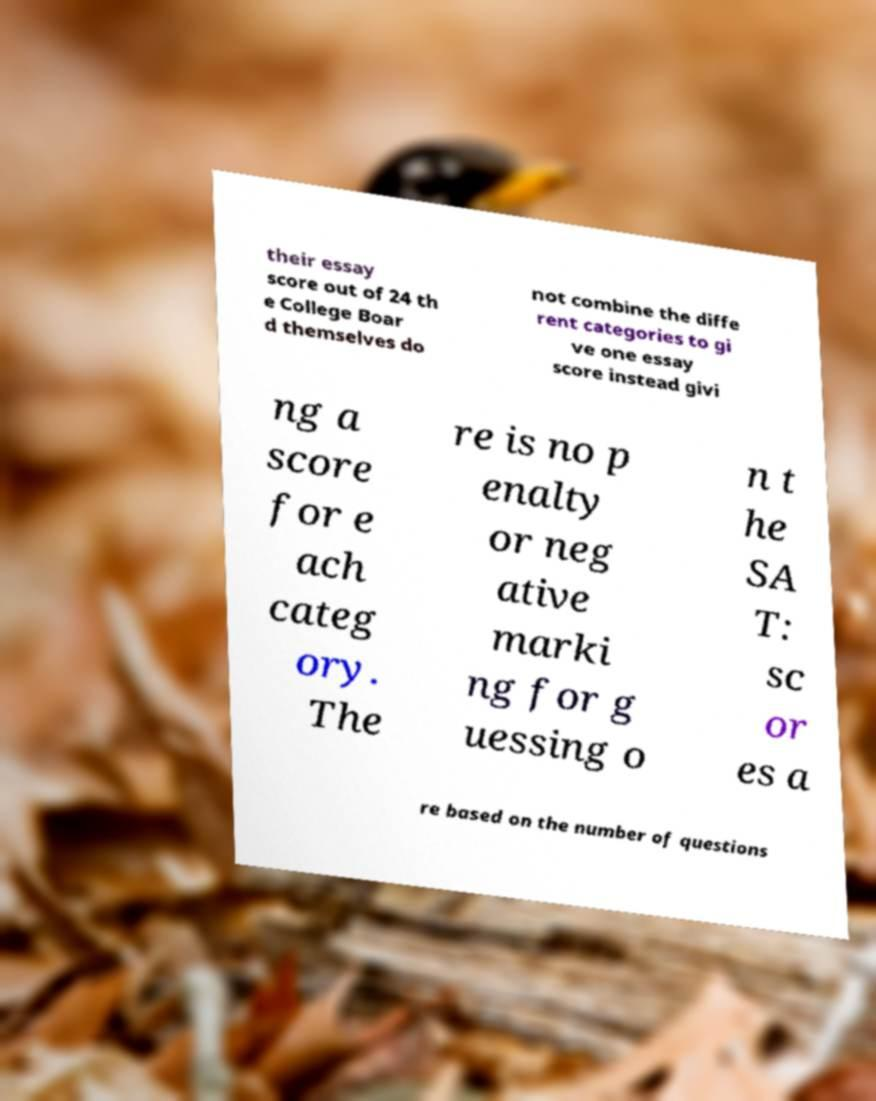Could you assist in decoding the text presented in this image and type it out clearly? their essay score out of 24 th e College Boar d themselves do not combine the diffe rent categories to gi ve one essay score instead givi ng a score for e ach categ ory. The re is no p enalty or neg ative marki ng for g uessing o n t he SA T: sc or es a re based on the number of questions 